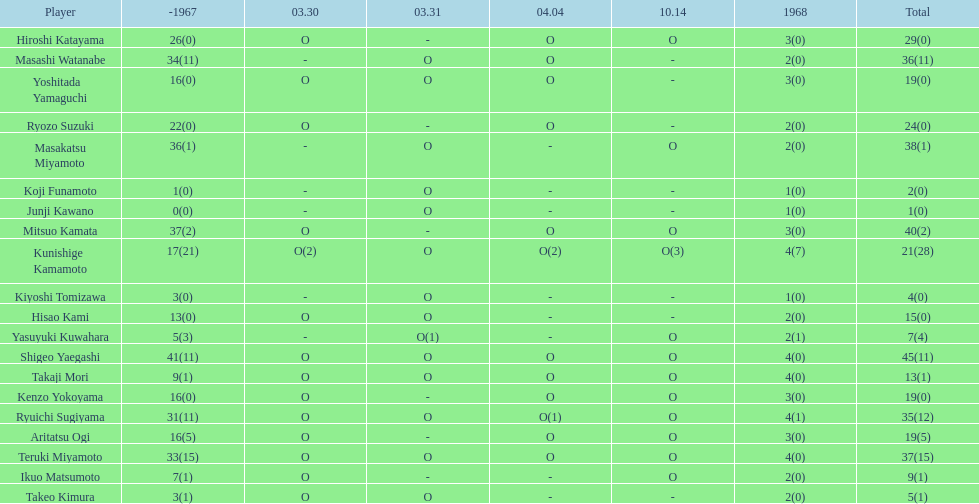How many more total appearances did shigeo yaegashi have than mitsuo kamata? 5. 